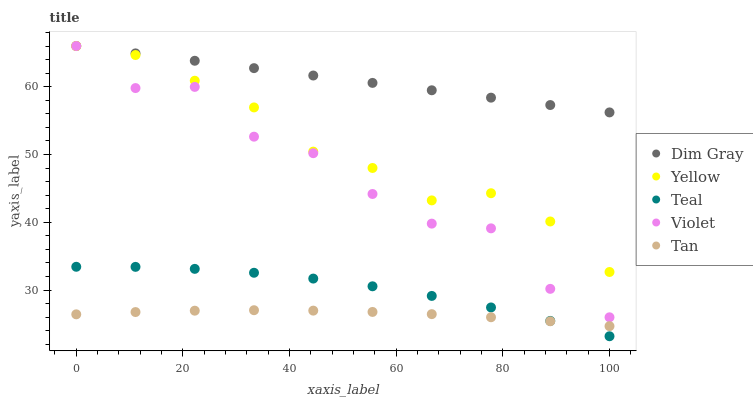Does Tan have the minimum area under the curve?
Answer yes or no. Yes. Does Dim Gray have the maximum area under the curve?
Answer yes or no. Yes. Does Teal have the minimum area under the curve?
Answer yes or no. No. Does Teal have the maximum area under the curve?
Answer yes or no. No. Is Dim Gray the smoothest?
Answer yes or no. Yes. Is Violet the roughest?
Answer yes or no. Yes. Is Teal the smoothest?
Answer yes or no. No. Is Teal the roughest?
Answer yes or no. No. Does Teal have the lowest value?
Answer yes or no. Yes. Does Dim Gray have the lowest value?
Answer yes or no. No. Does Violet have the highest value?
Answer yes or no. Yes. Does Teal have the highest value?
Answer yes or no. No. Is Teal less than Yellow?
Answer yes or no. Yes. Is Violet greater than Tan?
Answer yes or no. Yes. Does Teal intersect Tan?
Answer yes or no. Yes. Is Teal less than Tan?
Answer yes or no. No. Is Teal greater than Tan?
Answer yes or no. No. Does Teal intersect Yellow?
Answer yes or no. No. 